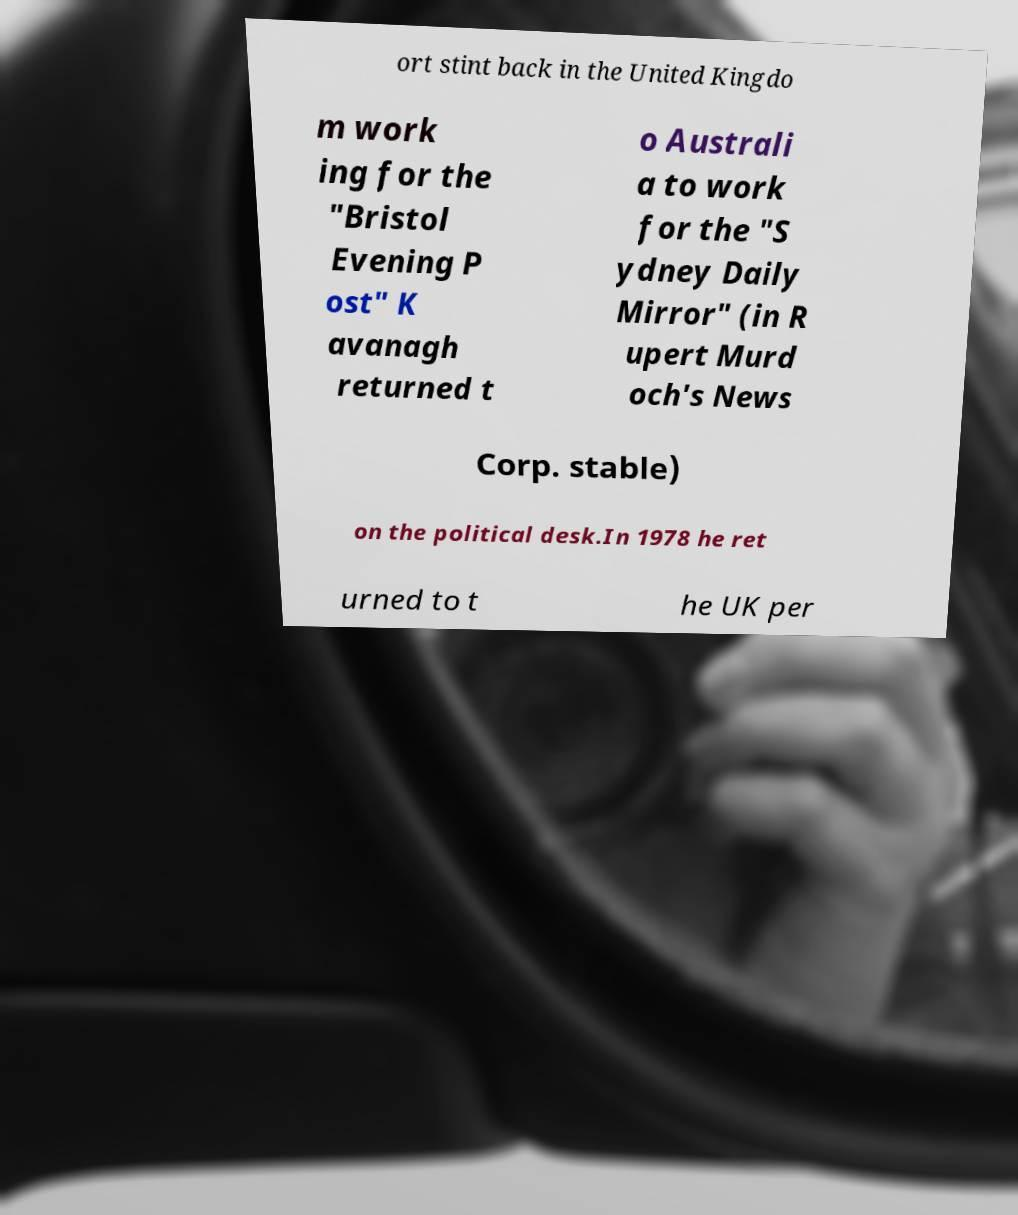Could you extract and type out the text from this image? ort stint back in the United Kingdo m work ing for the "Bristol Evening P ost" K avanagh returned t o Australi a to work for the "S ydney Daily Mirror" (in R upert Murd och's News Corp. stable) on the political desk.In 1978 he ret urned to t he UK per 